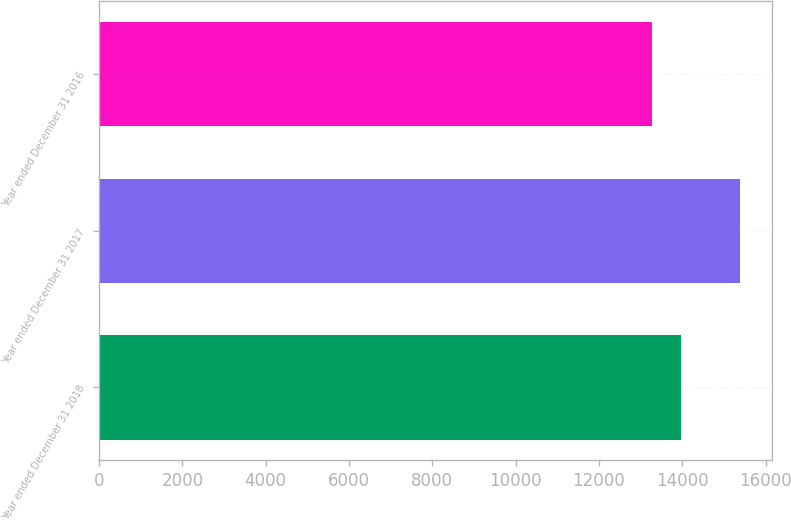Convert chart. <chart><loc_0><loc_0><loc_500><loc_500><bar_chart><fcel>Year ended December 31 2018<fcel>Year ended December 31 2017<fcel>Year ended December 31 2016<nl><fcel>13970<fcel>15387<fcel>13280<nl></chart> 